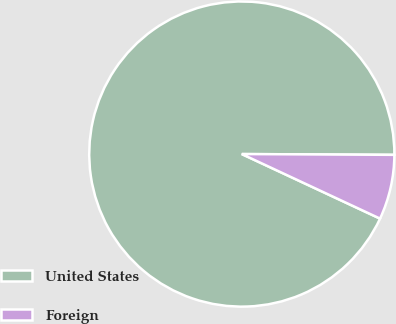Convert chart. <chart><loc_0><loc_0><loc_500><loc_500><pie_chart><fcel>United States<fcel>Foreign<nl><fcel>93.13%<fcel>6.87%<nl></chart> 